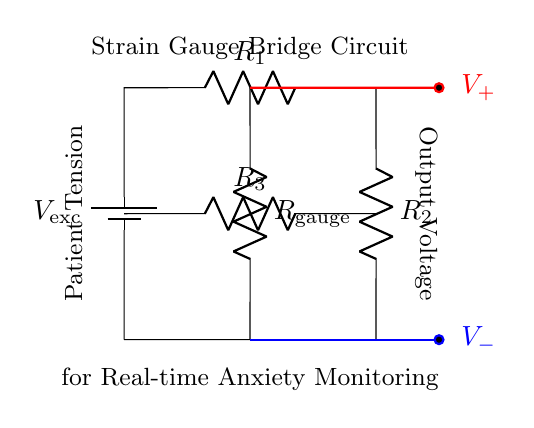What is the voltage source in the circuit? The voltage source is labeled as V_ex with the notation of a battery, indicating it provides the excitation voltage needed for the strain gauge bridge circuit.
Answer: V_exc What are the resistances used in the circuit? The resistances in the circuit are labeled R_1, R_2, and R_3, as well as the strain gauge labeled R_gauge. All are resistors that play a role in the bridge circuit's function.
Answer: R_1, R_2, R_3, R_gauge What does the output voltage represent? The output voltage, represented by V_+ and V_-, indicates the potential difference across the strain gauge due to changes in the patient's tension, therefore reflecting their physical state.
Answer: Patient Tension How many resistors are part of the gauge bridge? There are four resistors in total, which include R_1, R_2, R_3, and R_gauge, all connected in a bridge configuration.
Answer: Four What is the purpose of the strain gauge in this circuit? The strain gauge serves to measure the physical tension variations in the patient, translating these changes into measurable electrical signals through the bridge circuit configuration.
Answer: Measure tension How does the strain gauge affect voltage output? The strain gauge alters the bridge balance when the tension on the patient changes, which leads to an imbalance and thus a change in the output voltage readings, indicating the level of tension or relaxation.
Answer: Changes voltage output 